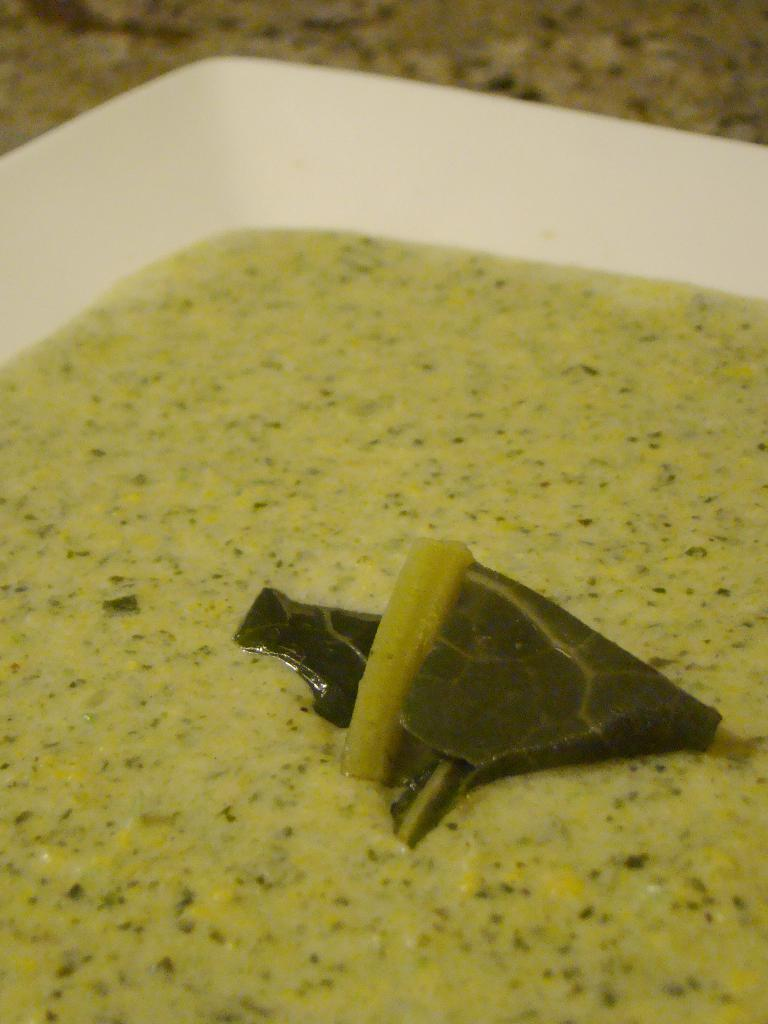What object is present in the image that typically holds food? There is a plate in the image. What is on the plate in the image? The plate contains food. What type of humor can be seen in the image? There is no humor present in the image; it simply shows a plate with food. 